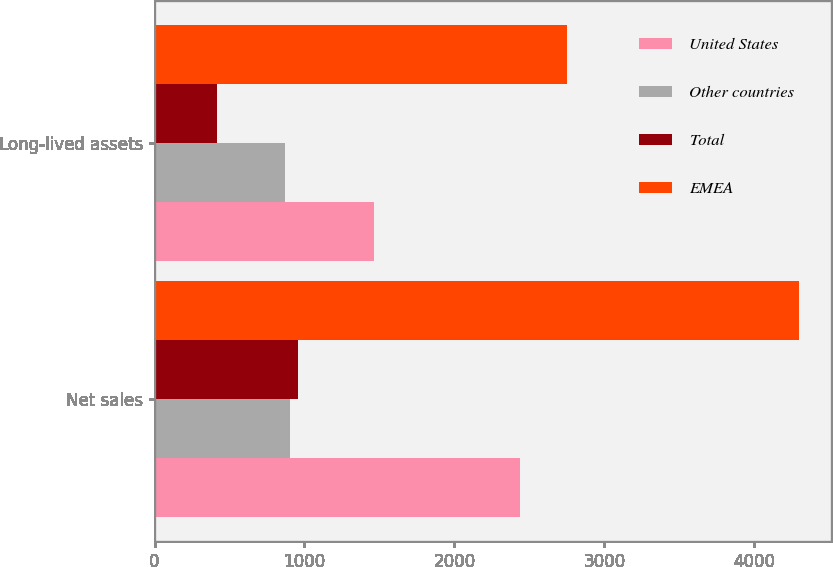Convert chart. <chart><loc_0><loc_0><loc_500><loc_500><stacked_bar_chart><ecel><fcel>Net sales<fcel>Long-lived assets<nl><fcel>United States<fcel>2438.1<fcel>1462.2<nl><fcel>Other countries<fcel>903.7<fcel>871.9<nl><fcel>Total<fcel>954.5<fcel>415.7<nl><fcel>EMEA<fcel>4296.3<fcel>2749.8<nl></chart> 